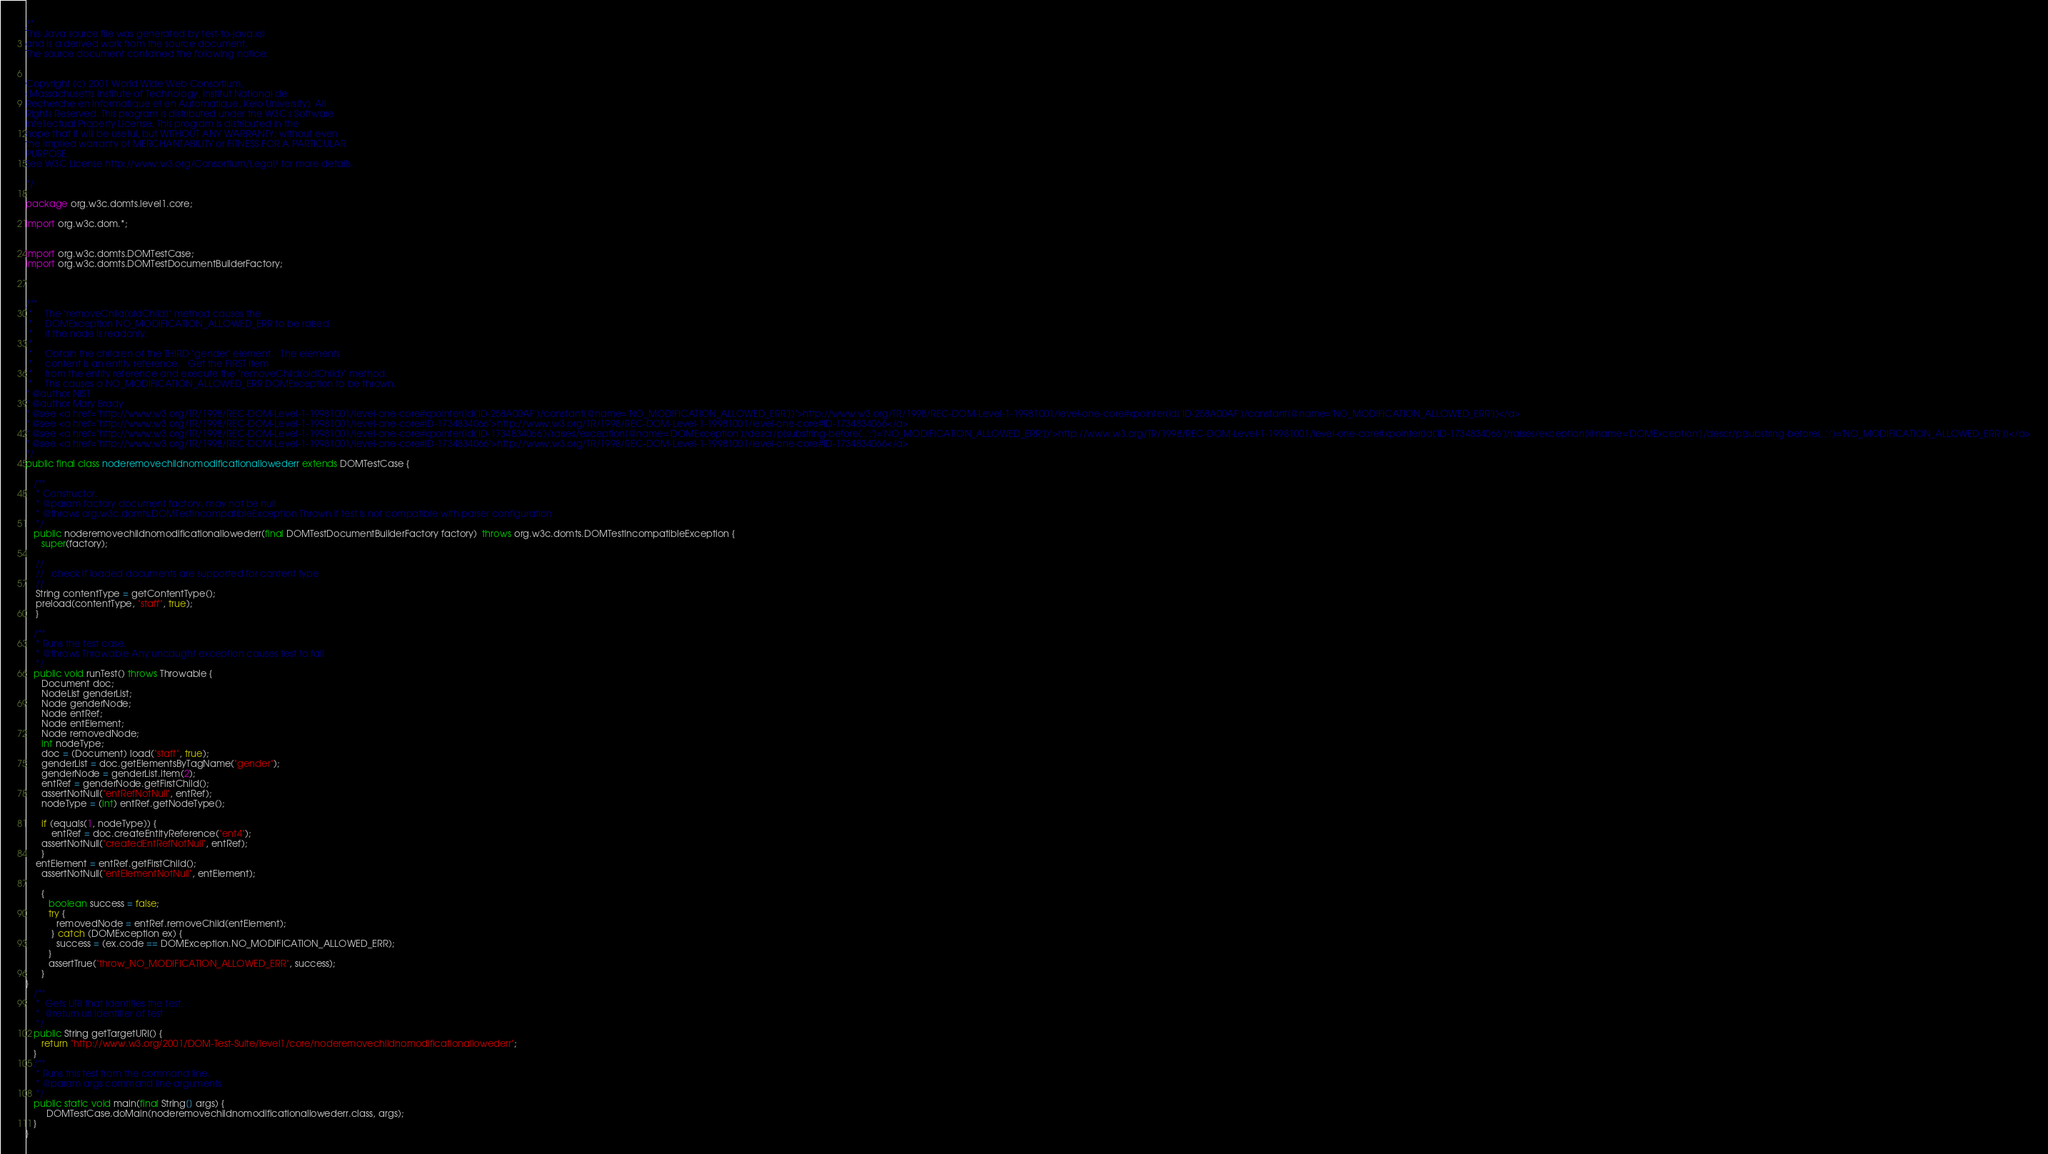Convert code to text. <code><loc_0><loc_0><loc_500><loc_500><_Java_>
/*
This Java source file was generated by test-to-java.xsl
and is a derived work from the source document.
The source document contained the following notice:


Copyright (c) 2001 World Wide Web Consortium,
(Massachusetts Institute of Technology, Institut National de
Recherche en Informatique et en Automatique, Keio University). All
Rights Reserved. This program is distributed under the W3C's Software
Intellectual Property License. This program is distributed in the
hope that it will be useful, but WITHOUT ANY WARRANTY; without even
the implied warranty of MERCHANTABILITY or FITNESS FOR A PARTICULAR
PURPOSE.
See W3C License http://www.w3.org/Consortium/Legal/ for more details.

*/

package org.w3c.domts.level1.core;

import org.w3c.dom.*;


import org.w3c.domts.DOMTestCase;
import org.w3c.domts.DOMTestDocumentBuilderFactory;



/**
 *     The "removeChild(oldChild)" method causes the 
 *     DOMException NO_MODIFICATION_ALLOWED_ERR to be raised
 *     if the node is readonly.
 *     
 *     Obtain the children of the THIRD "gender" element.   The elements
 *     content is an entity reference.   Get the FIRST item 
 *     from the entity reference and execute the "removeChild(oldChild)" method.
 *     This causes a NO_MODIFICATION_ALLOWED_ERR DOMException to be thrown.
* @author NIST
* @author Mary Brady
* @see <a href="http://www.w3.org/TR/1998/REC-DOM-Level-1-19981001/level-one-core#xpointer(id('ID-258A00AF')/constant[@name='NO_MODIFICATION_ALLOWED_ERR'])">http://www.w3.org/TR/1998/REC-DOM-Level-1-19981001/level-one-core#xpointer(id('ID-258A00AF')/constant[@name='NO_MODIFICATION_ALLOWED_ERR'])</a>
* @see <a href="http://www.w3.org/TR/1998/REC-DOM-Level-1-19981001/level-one-core#ID-1734834066">http://www.w3.org/TR/1998/REC-DOM-Level-1-19981001/level-one-core#ID-1734834066</a>
* @see <a href="http://www.w3.org/TR/1998/REC-DOM-Level-1-19981001/level-one-core#xpointer(id('ID-1734834066')/raises/exception[@name='DOMException']/descr/p[substring-before(.,':')='NO_MODIFICATION_ALLOWED_ERR'])">http://www.w3.org/TR/1998/REC-DOM-Level-1-19981001/level-one-core#xpointer(id('ID-1734834066')/raises/exception[@name='DOMException']/descr/p[substring-before(.,':')='NO_MODIFICATION_ALLOWED_ERR'])</a>
* @see <a href="http://www.w3.org/TR/1998/REC-DOM-Level-1-19981001/level-one-core#ID-1734834066">http://www.w3.org/TR/1998/REC-DOM-Level-1-19981001/level-one-core#ID-1734834066</a>
*/
public final class noderemovechildnomodificationallowederr extends DOMTestCase {

   /**
    * Constructor.
    * @param factory document factory, may not be null
    * @throws org.w3c.domts.DOMTestIncompatibleException Thrown if test is not compatible with parser configuration
    */
   public noderemovechildnomodificationallowederr(final DOMTestDocumentBuilderFactory factory)  throws org.w3c.domts.DOMTestIncompatibleException {
      super(factory);

    //
    //   check if loaded documents are supported for content type
    //
    String contentType = getContentType();
    preload(contentType, "staff", true);
    }

   /**
    * Runs the test case.
    * @throws Throwable Any uncaught exception causes test to fail
    */
   public void runTest() throws Throwable {
      Document doc;
      NodeList genderList;
      Node genderNode;
      Node entRef;
      Node entElement;
      Node removedNode;
      int nodeType;
      doc = (Document) load("staff", true);
      genderList = doc.getElementsByTagName("gender");
      genderNode = genderList.item(2);
      entRef = genderNode.getFirstChild();
      assertNotNull("entRefNotNull", entRef);
      nodeType = (int) entRef.getNodeType();
      
      if (equals(1, nodeType)) {
          entRef = doc.createEntityReference("ent4");
      assertNotNull("createdEntRefNotNull", entRef);
      }
    entElement = entRef.getFirstChild();
      assertNotNull("entElementNotNull", entElement);
      
      {
         boolean success = false;
         try {
            removedNode = entRef.removeChild(entElement);
          } catch (DOMException ex) {
            success = (ex.code == DOMException.NO_MODIFICATION_ALLOWED_ERR);
         }
         assertTrue("throw_NO_MODIFICATION_ALLOWED_ERR", success);
      }
}
   /**
    *  Gets URI that identifies the test.
    *  @return uri identifier of test
    */
   public String getTargetURI() {
      return "http://www.w3.org/2001/DOM-Test-Suite/level1/core/noderemovechildnomodificationallowederr";
   }
   /**
    * Runs this test from the command line.
    * @param args command line arguments
    */
   public static void main(final String[] args) {
        DOMTestCase.doMain(noderemovechildnomodificationallowederr.class, args);
   }
}

</code> 